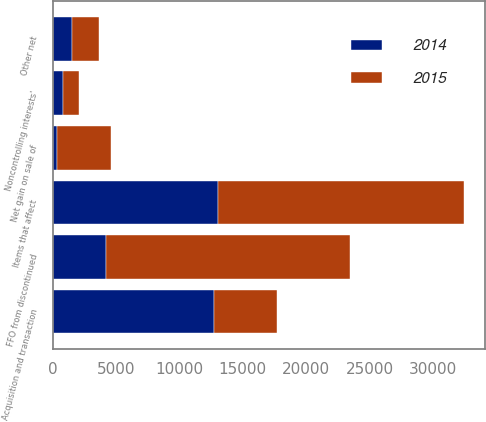<chart> <loc_0><loc_0><loc_500><loc_500><stacked_bar_chart><ecel><fcel>FFO from discontinued<fcel>Acquisition and transaction<fcel>Net gain on sale of<fcel>Other net<fcel>Noncontrolling interests'<fcel>Items that affect<nl><fcel>2015<fcel>19251<fcel>4951<fcel>4231<fcel>2171<fcel>1284<fcel>19418<nl><fcel>2014<fcel>4231<fcel>12763<fcel>363<fcel>1491<fcel>803<fcel>13033<nl></chart> 